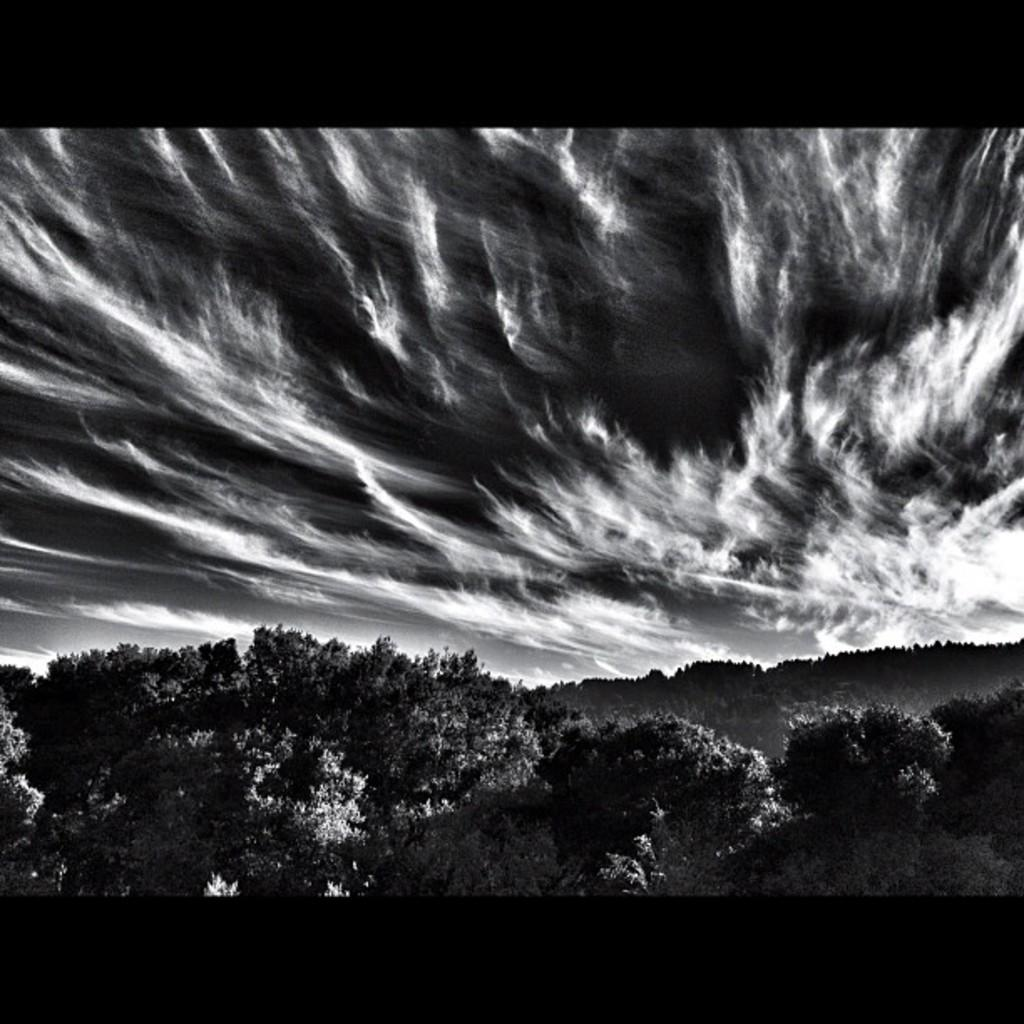What is the color scheme of the image? The image is black and white. What type of natural elements can be seen in the image? There are trees in the image. What part of the sky is visible in the image? The sky is visible in the image. What can be observed in the sky? Clouds are present in the sky. What design elements are present at the top and bottom of the image? There are borders at the top and bottom of the image. What type of crate is visible in the image? There is no crate present in the image. What kind of fruit is hanging from the trees in the image? There are no fruits visible on the trees in the image. 